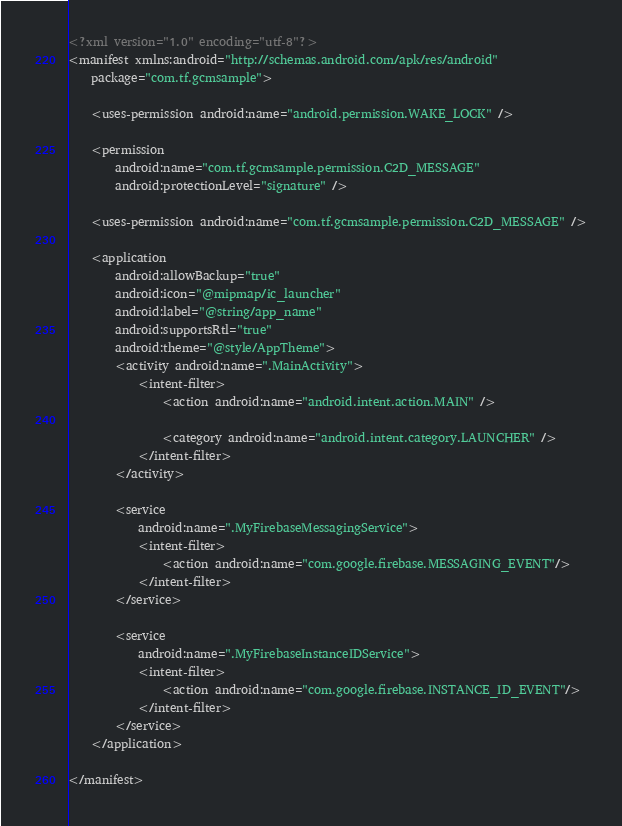Convert code to text. <code><loc_0><loc_0><loc_500><loc_500><_XML_><?xml version="1.0" encoding="utf-8"?>
<manifest xmlns:android="http://schemas.android.com/apk/res/android"
    package="com.tf.gcmsample">

    <uses-permission android:name="android.permission.WAKE_LOCK" />

    <permission
        android:name="com.tf.gcmsample.permission.C2D_MESSAGE"
        android:protectionLevel="signature" />

    <uses-permission android:name="com.tf.gcmsample.permission.C2D_MESSAGE" />

    <application
        android:allowBackup="true"
        android:icon="@mipmap/ic_launcher"
        android:label="@string/app_name"
        android:supportsRtl="true"
        android:theme="@style/AppTheme">
        <activity android:name=".MainActivity">
            <intent-filter>
                <action android:name="android.intent.action.MAIN" />

                <category android:name="android.intent.category.LAUNCHER" />
            </intent-filter>
        </activity>

        <service
            android:name=".MyFirebaseMessagingService">
            <intent-filter>
                <action android:name="com.google.firebase.MESSAGING_EVENT"/>
            </intent-filter>
        </service>

        <service
            android:name=".MyFirebaseInstanceIDService">
            <intent-filter>
                <action android:name="com.google.firebase.INSTANCE_ID_EVENT"/>
            </intent-filter>
        </service>
    </application>

</manifest>
</code> 